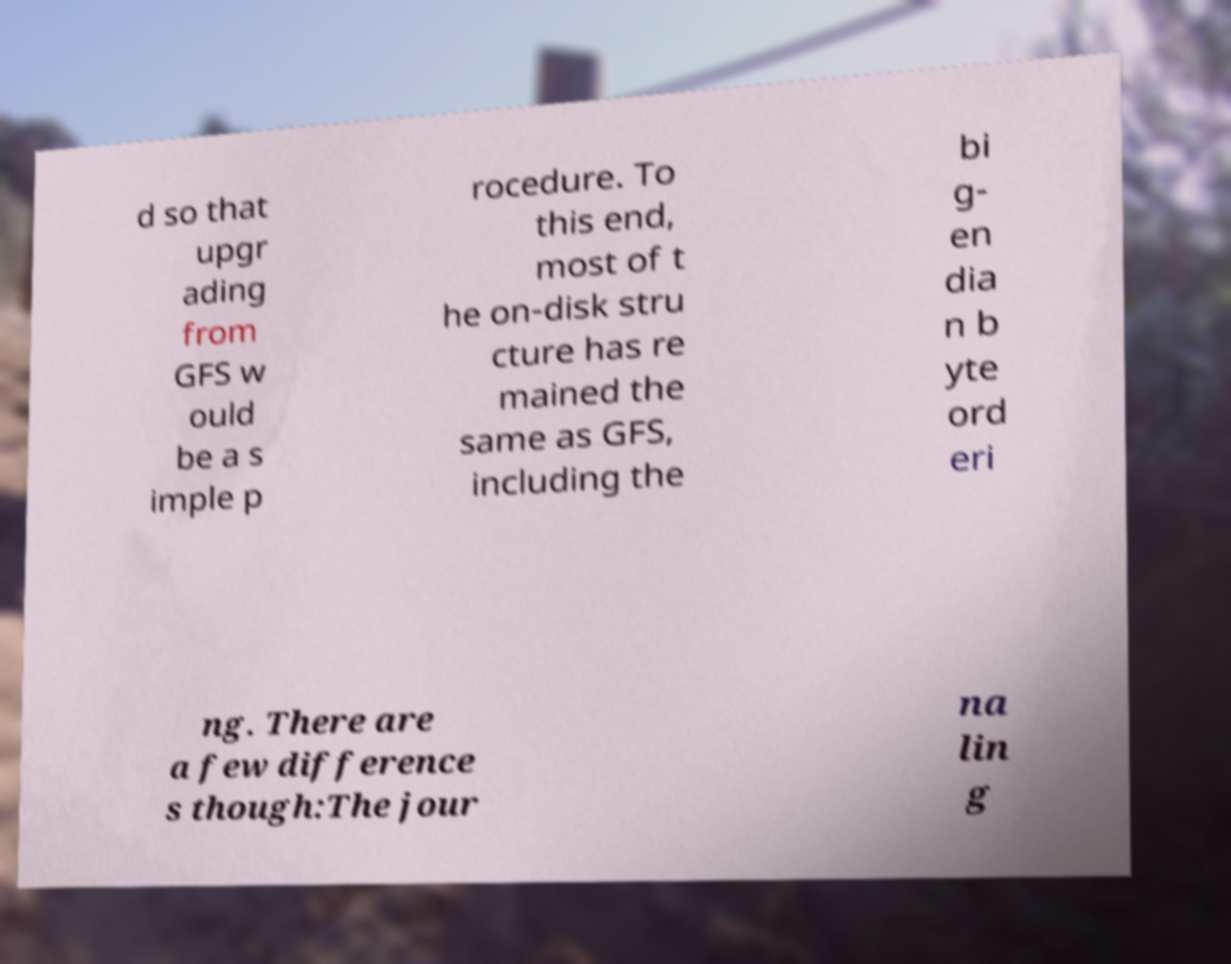Can you read and provide the text displayed in the image?This photo seems to have some interesting text. Can you extract and type it out for me? d so that upgr ading from GFS w ould be a s imple p rocedure. To this end, most of t he on-disk stru cture has re mained the same as GFS, including the bi g- en dia n b yte ord eri ng. There are a few difference s though:The jour na lin g 